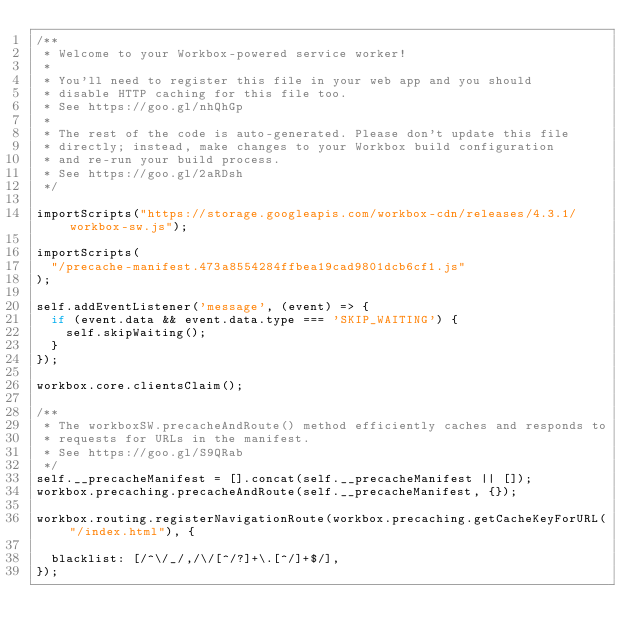<code> <loc_0><loc_0><loc_500><loc_500><_JavaScript_>/**
 * Welcome to your Workbox-powered service worker!
 *
 * You'll need to register this file in your web app and you should
 * disable HTTP caching for this file too.
 * See https://goo.gl/nhQhGp
 *
 * The rest of the code is auto-generated. Please don't update this file
 * directly; instead, make changes to your Workbox build configuration
 * and re-run your build process.
 * See https://goo.gl/2aRDsh
 */

importScripts("https://storage.googleapis.com/workbox-cdn/releases/4.3.1/workbox-sw.js");

importScripts(
  "/precache-manifest.473a8554284ffbea19cad9801dcb6cf1.js"
);

self.addEventListener('message', (event) => {
  if (event.data && event.data.type === 'SKIP_WAITING') {
    self.skipWaiting();
  }
});

workbox.core.clientsClaim();

/**
 * The workboxSW.precacheAndRoute() method efficiently caches and responds to
 * requests for URLs in the manifest.
 * See https://goo.gl/S9QRab
 */
self.__precacheManifest = [].concat(self.__precacheManifest || []);
workbox.precaching.precacheAndRoute(self.__precacheManifest, {});

workbox.routing.registerNavigationRoute(workbox.precaching.getCacheKeyForURL("/index.html"), {
  
  blacklist: [/^\/_/,/\/[^/?]+\.[^/]+$/],
});
</code> 